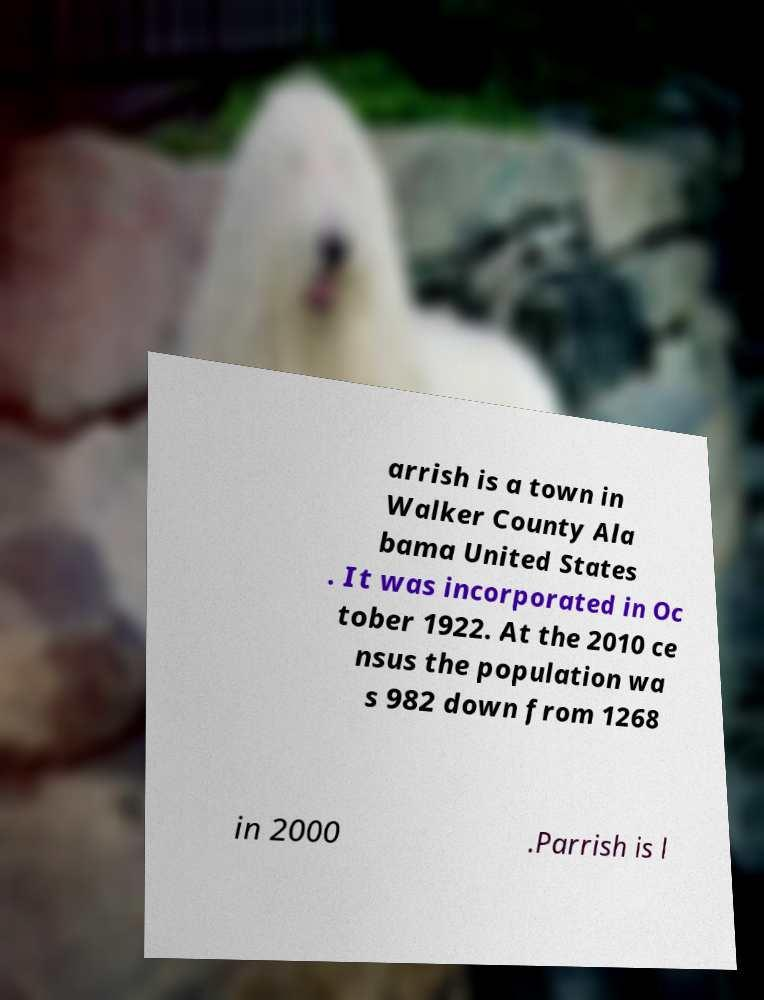Can you accurately transcribe the text from the provided image for me? arrish is a town in Walker County Ala bama United States . It was incorporated in Oc tober 1922. At the 2010 ce nsus the population wa s 982 down from 1268 in 2000 .Parrish is l 